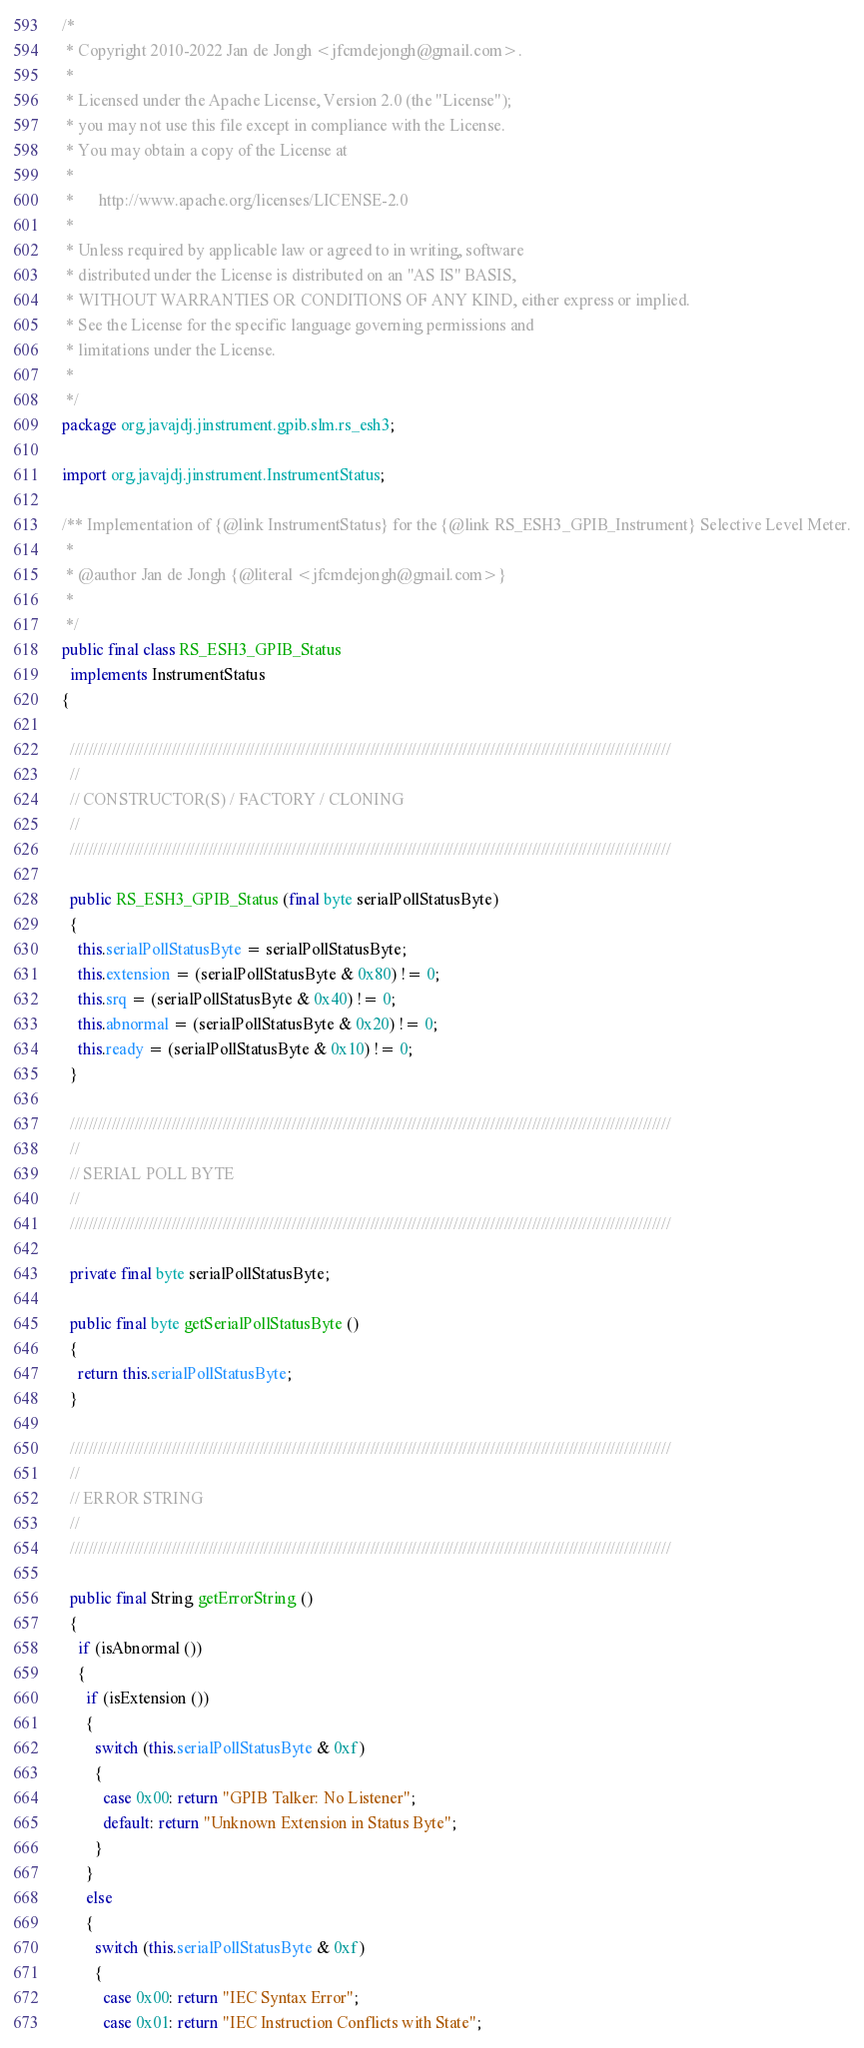<code> <loc_0><loc_0><loc_500><loc_500><_Java_>/*
 * Copyright 2010-2022 Jan de Jongh <jfcmdejongh@gmail.com>.
 *
 * Licensed under the Apache License, Version 2.0 (the "License");
 * you may not use this file except in compliance with the License.
 * You may obtain a copy of the License at
 *
 *      http://www.apache.org/licenses/LICENSE-2.0
 *
 * Unless required by applicable law or agreed to in writing, software
 * distributed under the License is distributed on an "AS IS" BASIS,
 * WITHOUT WARRANTIES OR CONDITIONS OF ANY KIND, either express or implied.
 * See the License for the specific language governing permissions and
 * limitations under the License.
 * 
 */
package org.javajdj.jinstrument.gpib.slm.rs_esh3;

import org.javajdj.jinstrument.InstrumentStatus;

/** Implementation of {@link InstrumentStatus} for the {@link RS_ESH3_GPIB_Instrument} Selective Level Meter.
 *
 * @author Jan de Jongh {@literal <jfcmdejongh@gmail.com>}
 * 
 */
public final class RS_ESH3_GPIB_Status
  implements InstrumentStatus
{
  
  //////////////////////////////////////////////////////////////////////////////////////////////////////////////////////////////////
  //
  // CONSTRUCTOR(S) / FACTORY / CLONING
  //
  //////////////////////////////////////////////////////////////////////////////////////////////////////////////////////////////////
  
  public RS_ESH3_GPIB_Status (final byte serialPollStatusByte)
  {
    this.serialPollStatusByte = serialPollStatusByte;
    this.extension = (serialPollStatusByte & 0x80) != 0;
    this.srq = (serialPollStatusByte & 0x40) != 0;
    this.abnormal = (serialPollStatusByte & 0x20) != 0;
    this.ready = (serialPollStatusByte & 0x10) != 0;
  }

  //////////////////////////////////////////////////////////////////////////////////////////////////////////////////////////////////
  //
  // SERIAL POLL BYTE
  //
  //////////////////////////////////////////////////////////////////////////////////////////////////////////////////////////////////
  
  private final byte serialPollStatusByte;

  public final byte getSerialPollStatusByte ()
  {
    return this.serialPollStatusByte;
  }
  
  //////////////////////////////////////////////////////////////////////////////////////////////////////////////////////////////////
  //
  // ERROR STRING
  //
  //////////////////////////////////////////////////////////////////////////////////////////////////////////////////////////////////
  
  public final String getErrorString ()
  {
    if (isAbnormal ())
    {
      if (isExtension ())
      {
        switch (this.serialPollStatusByte & 0xf)
        {
          case 0x00: return "GPIB Talker: No Listener";
          default: return "Unknown Extension in Status Byte";
        }
      }
      else
      {
        switch (this.serialPollStatusByte & 0xf)
        {
          case 0x00: return "IEC Syntax Error";
          case 0x01: return "IEC Instruction Conflicts with State";</code> 